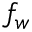<formula> <loc_0><loc_0><loc_500><loc_500>f _ { w }</formula> 